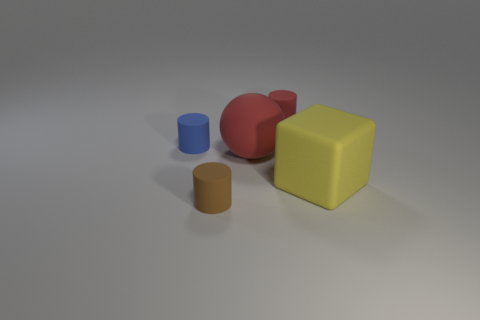Are the large block and the red thing that is on the left side of the small red matte cylinder made of the same material?
Give a very brief answer. Yes. What number of other objects are the same shape as the large yellow rubber thing?
Provide a short and direct response. 0. Do the ball and the tiny rubber thing in front of the blue matte cylinder have the same color?
Keep it short and to the point. No. Is there any other thing that is the same material as the small red cylinder?
Provide a succinct answer. Yes. There is a rubber object on the left side of the small cylinder that is in front of the rubber cube; what shape is it?
Your answer should be compact. Cylinder. There is a thing that is the same color as the ball; what size is it?
Offer a terse response. Small. Do the red rubber object in front of the blue matte object and the small blue thing have the same shape?
Offer a very short reply. No. Are there more tiny red rubber cylinders in front of the tiny brown thing than red cylinders left of the blue rubber cylinder?
Offer a terse response. No. There is a red object that is behind the red matte sphere; what number of red rubber objects are in front of it?
Give a very brief answer. 1. There is a small cylinder that is the same color as the big matte ball; what is its material?
Keep it short and to the point. Rubber. 